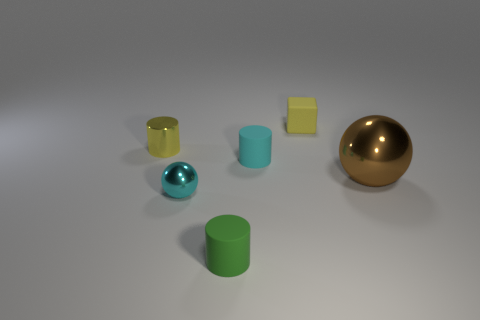Is there any other thing that has the same size as the brown metal sphere?
Provide a short and direct response. No. There is a metallic thing that is in front of the brown ball; is it the same size as the yellow object in front of the tiny yellow cube?
Provide a succinct answer. Yes. What is the shape of the metal thing to the left of the cyan ball?
Offer a terse response. Cylinder. The large sphere is what color?
Offer a terse response. Brown. Do the green rubber cylinder and the yellow thing that is to the right of the green matte thing have the same size?
Ensure brevity in your answer.  Yes. What number of metallic things are either tiny green cylinders or large gray cylinders?
Make the answer very short. 0. Is the color of the large object the same as the tiny matte cylinder that is in front of the brown object?
Your response must be concise. No. What is the shape of the green matte object?
Your response must be concise. Cylinder. There is a cyan object behind the ball left of the rubber thing that is behind the tiny yellow shiny object; what is its size?
Offer a terse response. Small. How many other things are the same shape as the tiny yellow metallic object?
Provide a succinct answer. 2. 